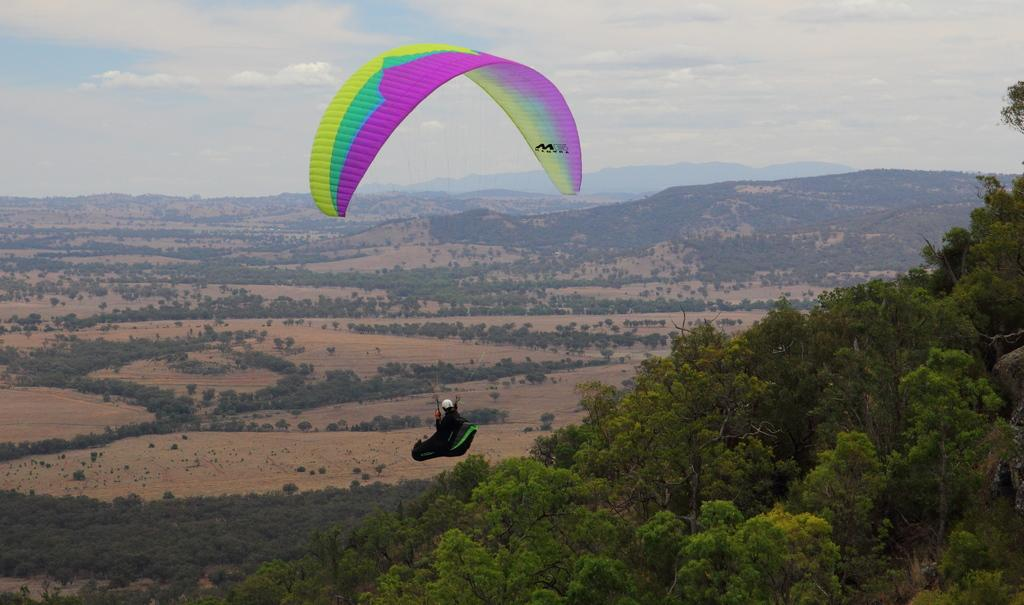What activity is the person in the image engaged in? The person is paragliding in the image. Where is the person paragliding located in the image? The person is in the center of the image. What type of landscape can be seen in the image? There are trees and mountains visible in the image. What is visible at the top of the image? The sky is visible at the top of the image. What verse is being recited on the stage in the image? There is no stage or verse present in the image; it features a person paragliding with trees, mountains, and the sky visible. 